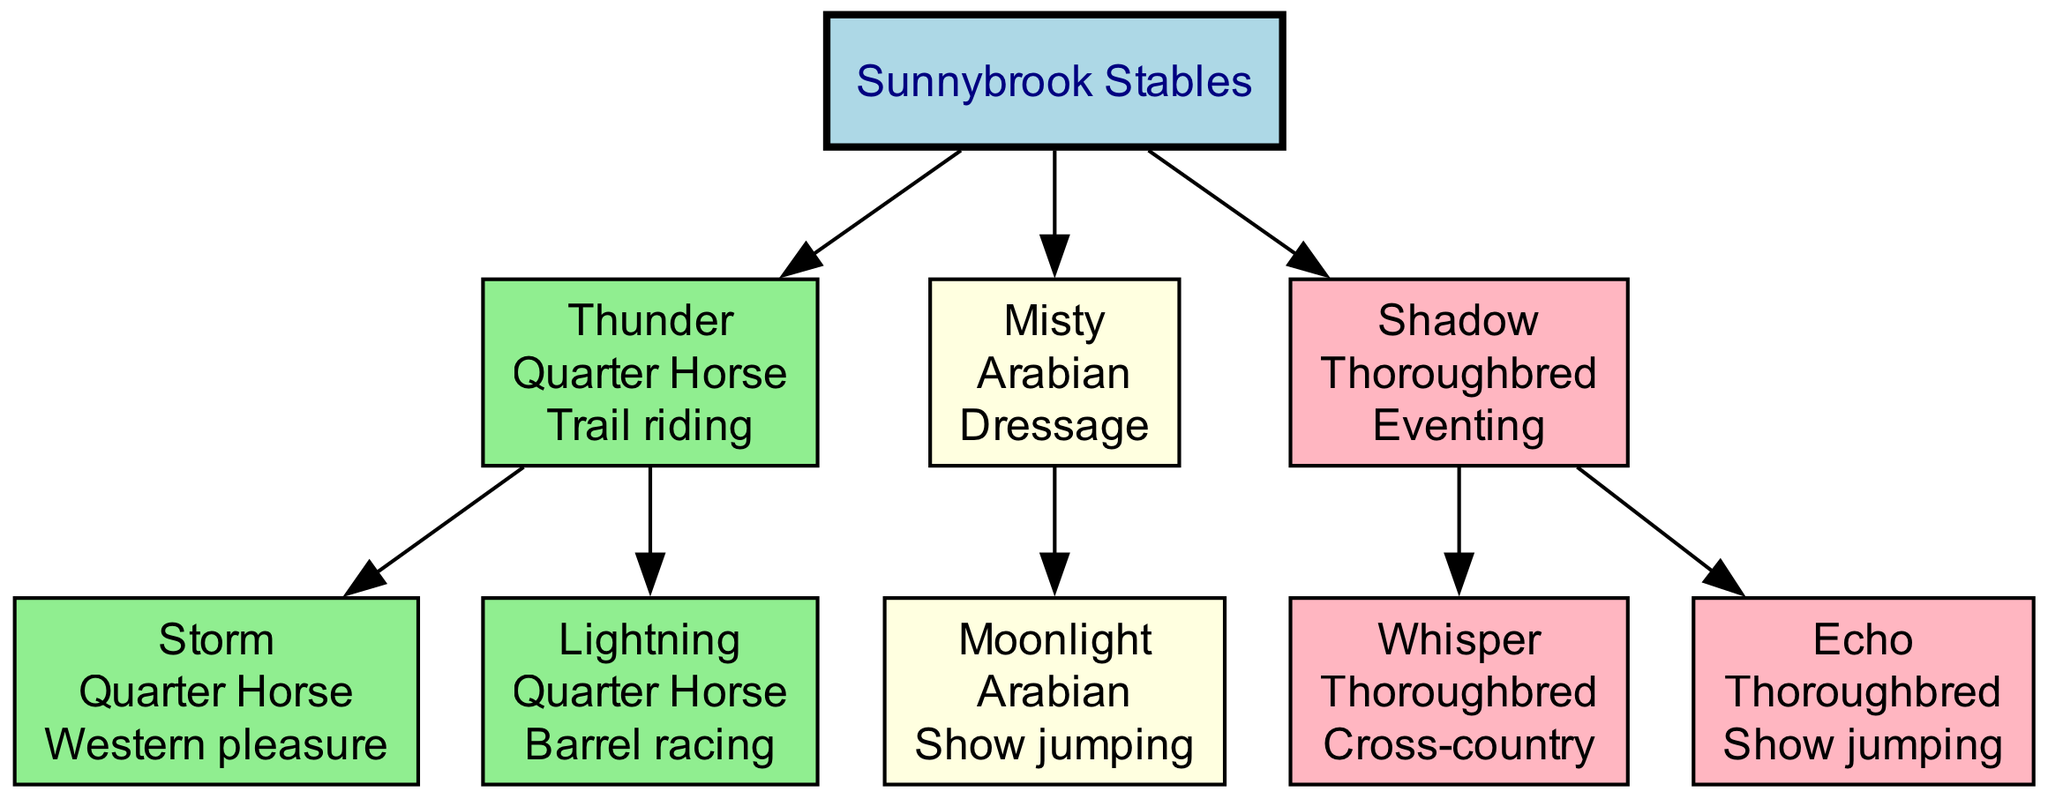What is the name of the root node in the family tree? The root node is labeled "Sunnybrook Stables", which represents the stable where all the horses are housed.
Answer: Sunnybrook Stables How many horses are there in the tree? There are three main horses listed in the tree: Thunder, Misty, and Shadow, hence the answer is derived directly from counting them.
Answer: 3 Which horse is known for trail riding? The horse labeled "Thunder" in the diagram has the specialty of trail riding, which is shown alongside its details.
Answer: Thunder What breed is the horse "Storm"? The horse "Storm" is a Quarter Horse, indicated by its details displayed in its node.
Answer: Quarter Horse Which specialty does "Moonlight" excel in? The specialization of "Moonlight" is shown as "Show jumping" in the diagram, clearly stated under its name and breed.
Answer: Show jumping How many offspring does "Shadow" have? "Shadow" has two offspring: "Whisper" and "Echo", which can be counted directly from the branches coming off of "Shadow" in the tree.
Answer: 2 Which horse specializes in eventing and what is its breed? The horse specializing in eventing is "Shadow", and its breed is Thoroughbred, as detailed next to its name in the diagram.
Answer: Shadow, Thoroughbred What color is the node representing Misty? The node for Misty is filled with light yellow color, which represents its breed, Arabian.
Answer: Light yellow What relationships can be found under the horse “Thunder”? The relationships under Thunder are its offspring "Storm" and "Lightning", indicated by the edges connected to its node representing parental connections.
Answer: Storm, Lightning Which horse specializes in barrel racing? The horse that specializes in barrel racing is "Lightning", as indicated in the diagram along with its details in the node.
Answer: Lightning 